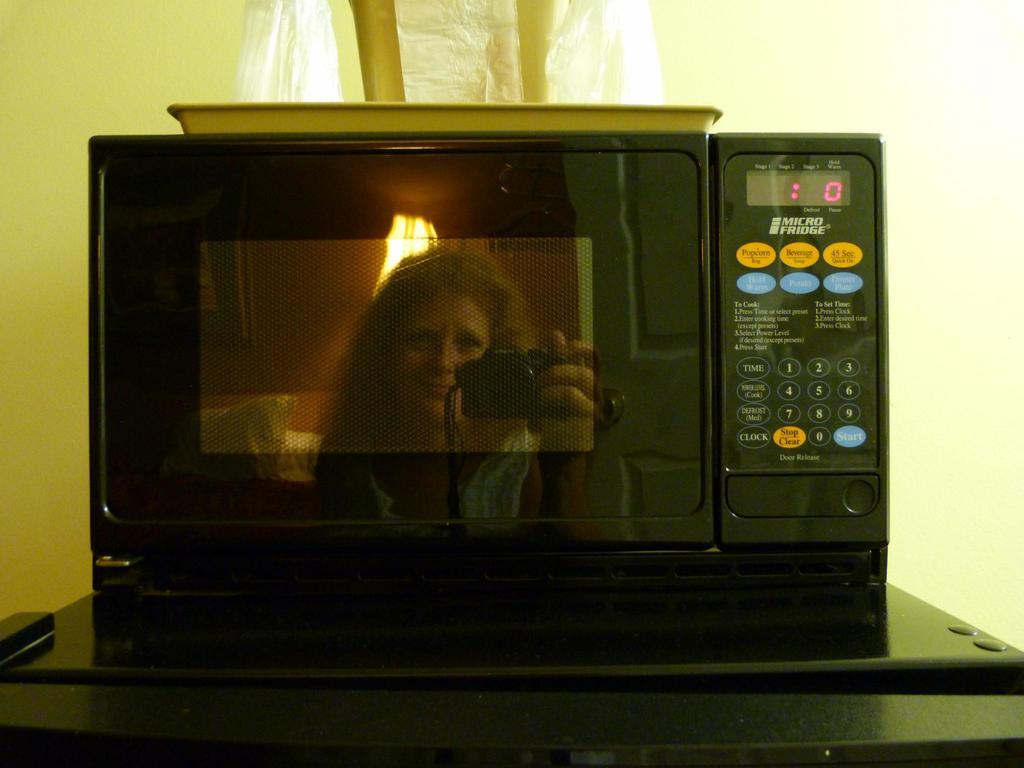<image>
Relay a brief, clear account of the picture shown. A black microwave oven with no time left on the timer. 